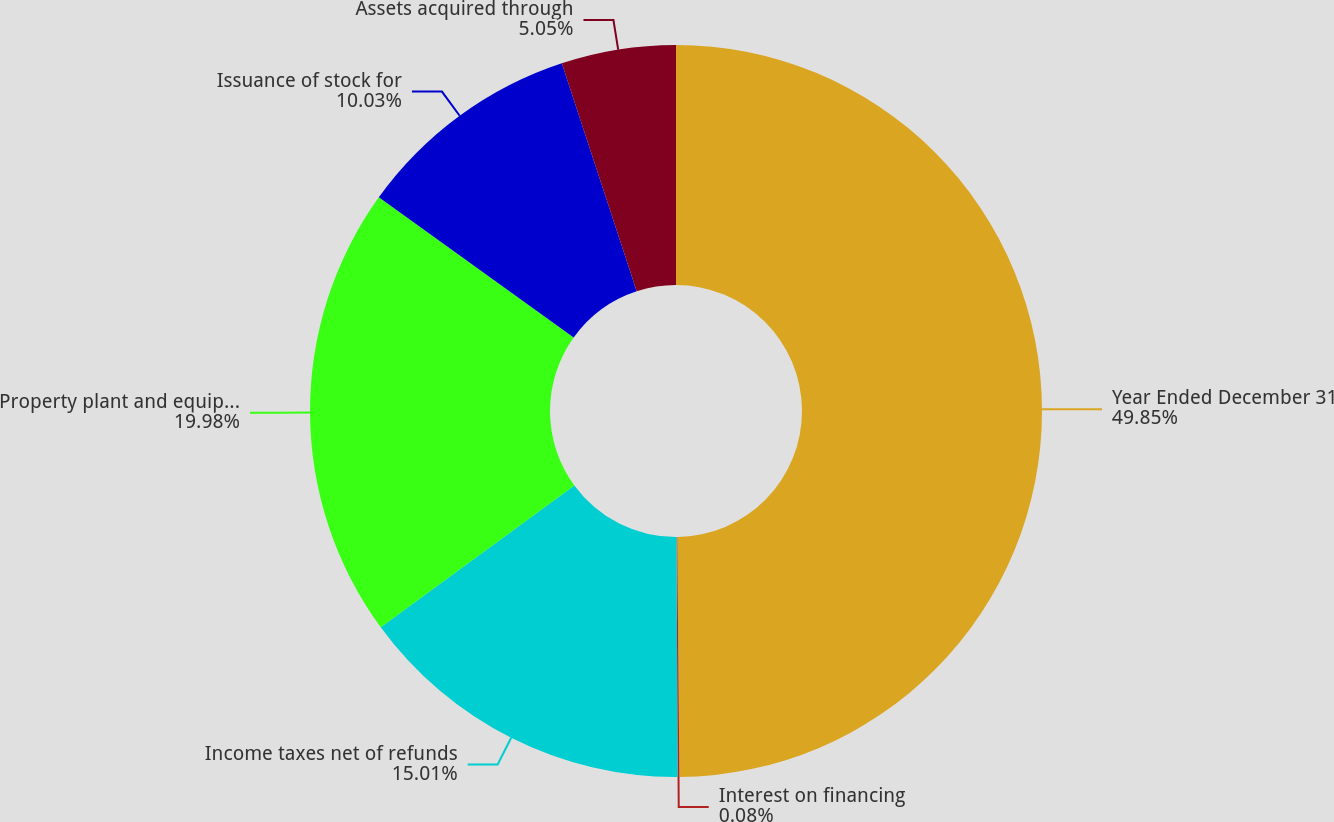Convert chart. <chart><loc_0><loc_0><loc_500><loc_500><pie_chart><fcel>Year Ended December 31<fcel>Interest on financing<fcel>Income taxes net of refunds<fcel>Property plant and equipment<fcel>Issuance of stock for<fcel>Assets acquired through<nl><fcel>49.85%<fcel>0.08%<fcel>15.01%<fcel>19.98%<fcel>10.03%<fcel>5.05%<nl></chart> 